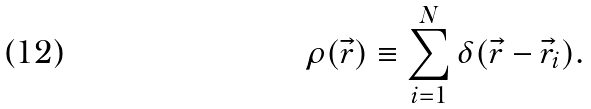<formula> <loc_0><loc_0><loc_500><loc_500>\rho ( \vec { r } ) \equiv \sum _ { i = 1 } ^ { N } \delta ( \vec { r } - \vec { r } _ { i } ) .</formula> 